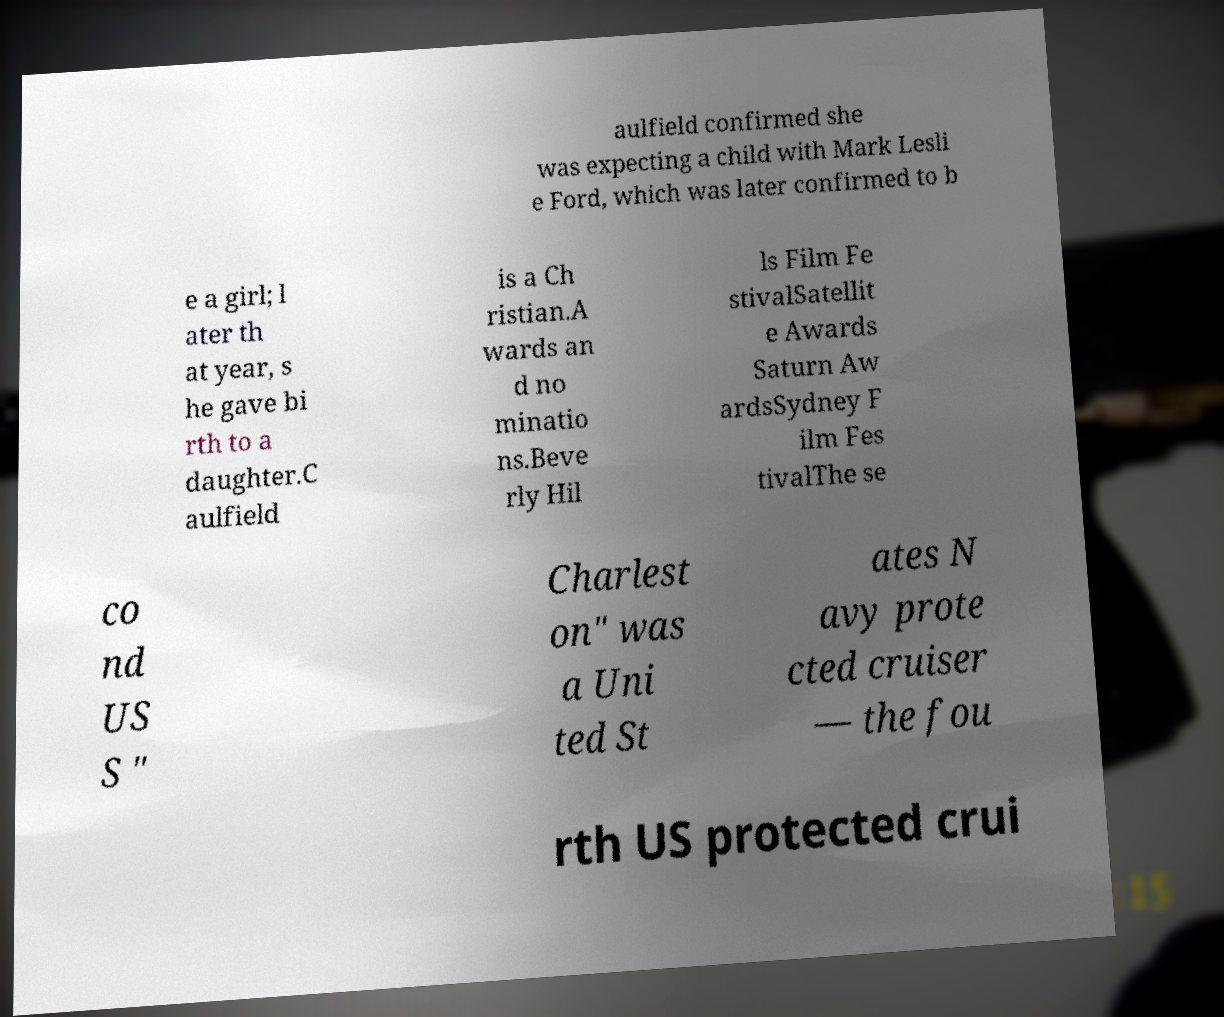Could you assist in decoding the text presented in this image and type it out clearly? aulfield confirmed she was expecting a child with Mark Lesli e Ford, which was later confirmed to b e a girl; l ater th at year, s he gave bi rth to a daughter.C aulfield is a Ch ristian.A wards an d no minatio ns.Beve rly Hil ls Film Fe stivalSatellit e Awards Saturn Aw ardsSydney F ilm Fes tivalThe se co nd US S " Charlest on" was a Uni ted St ates N avy prote cted cruiser — the fou rth US protected crui 